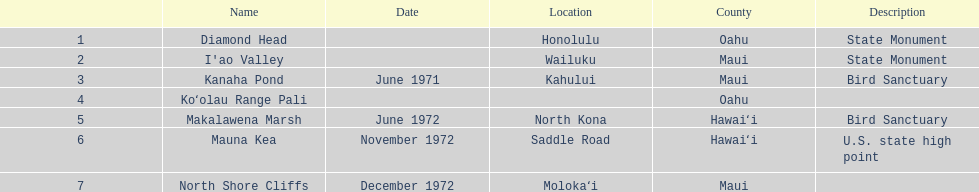What is the entire number of landmarks found in maui? 3. 